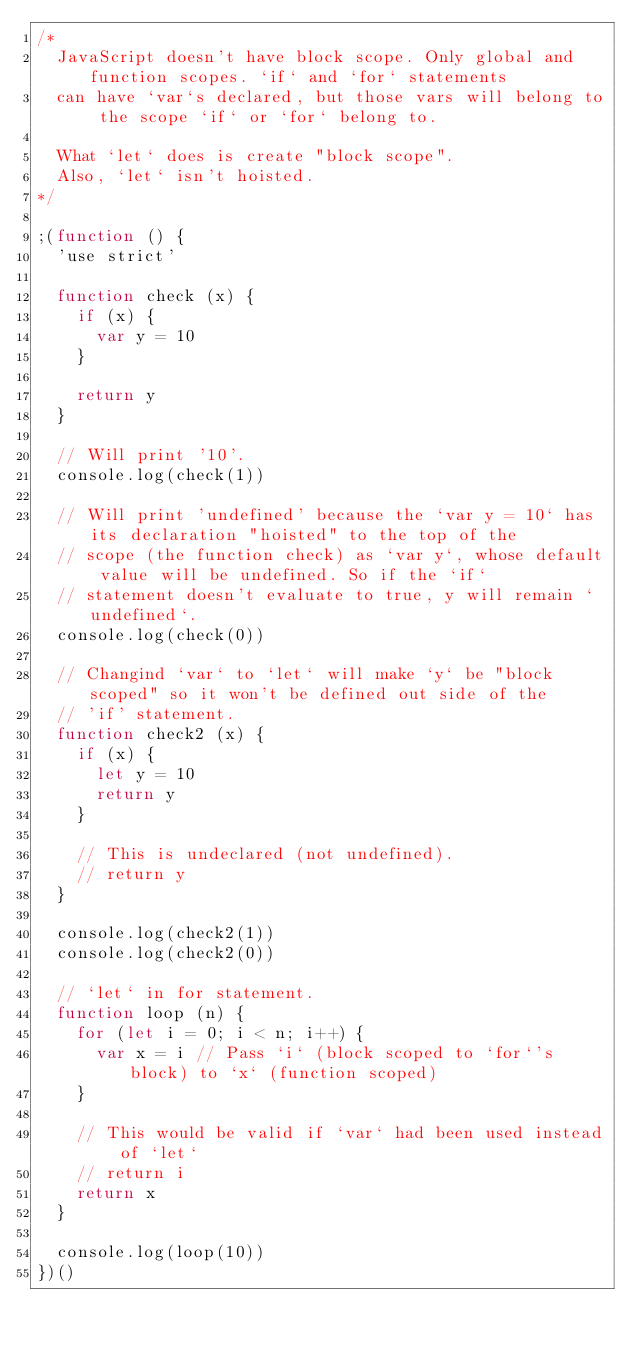Convert code to text. <code><loc_0><loc_0><loc_500><loc_500><_JavaScript_>/*
  JavaScript doesn't have block scope. Only global and function scopes. `if` and `for` statements
  can have `var`s declared, but those vars will belong to the scope `if` or `for` belong to.

  What `let` does is create "block scope".
  Also, `let` isn't hoisted.
*/

;(function () {
  'use strict'

  function check (x) {
    if (x) {
      var y = 10
    }

    return y
  }

  // Will print '10'.
  console.log(check(1))

  // Will print 'undefined' because the `var y = 10` has its declaration "hoisted" to the top of the
  // scope (the function check) as `var y`, whose default value will be undefined. So if the `if`
  // statement doesn't evaluate to true, y will remain `undefined`.
  console.log(check(0))

  // Changind `var` to `let` will make `y` be "block scoped" so it won't be defined out side of the
  // 'if' statement.
  function check2 (x) {
    if (x) {
      let y = 10
      return y
    }

    // This is undeclared (not undefined).
    // return y
  }

  console.log(check2(1))
  console.log(check2(0))

  // `let` in for statement.
  function loop (n) {
    for (let i = 0; i < n; i++) {
      var x = i // Pass `i` (block scoped to `for`'s block) to `x` (function scoped)
    }

    // This would be valid if `var` had been used instead of `let`
    // return i
    return x
  }

  console.log(loop(10))
})()
</code> 